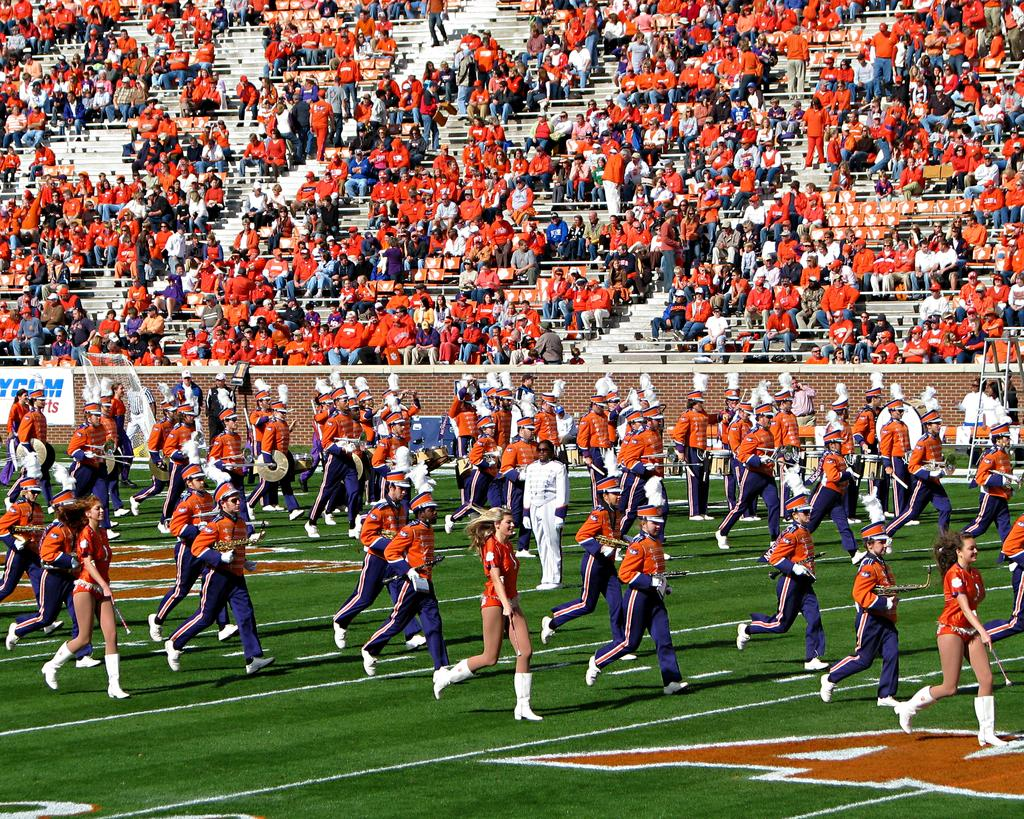What are the people in the image doing? The people in the image are marching on the ground at the bottom of the image. What can be seen in the background of the image? There is a crowd and bleaching chairs visible in the background of the image. What is located in the center of the image? There is a wall in the center of the image. What is the cast of the play performing in the image? There is no play or cast present in the image; it features people marching and a crowd in the background. 